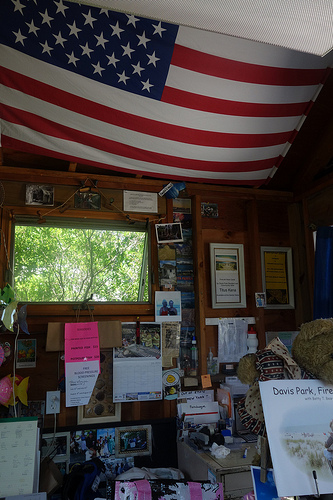<image>
Is the flag next to the ceiling? No. The flag is not positioned next to the ceiling. They are located in different areas of the scene. Is the photo to the left of the window? No. The photo is not to the left of the window. From this viewpoint, they have a different horizontal relationship. 